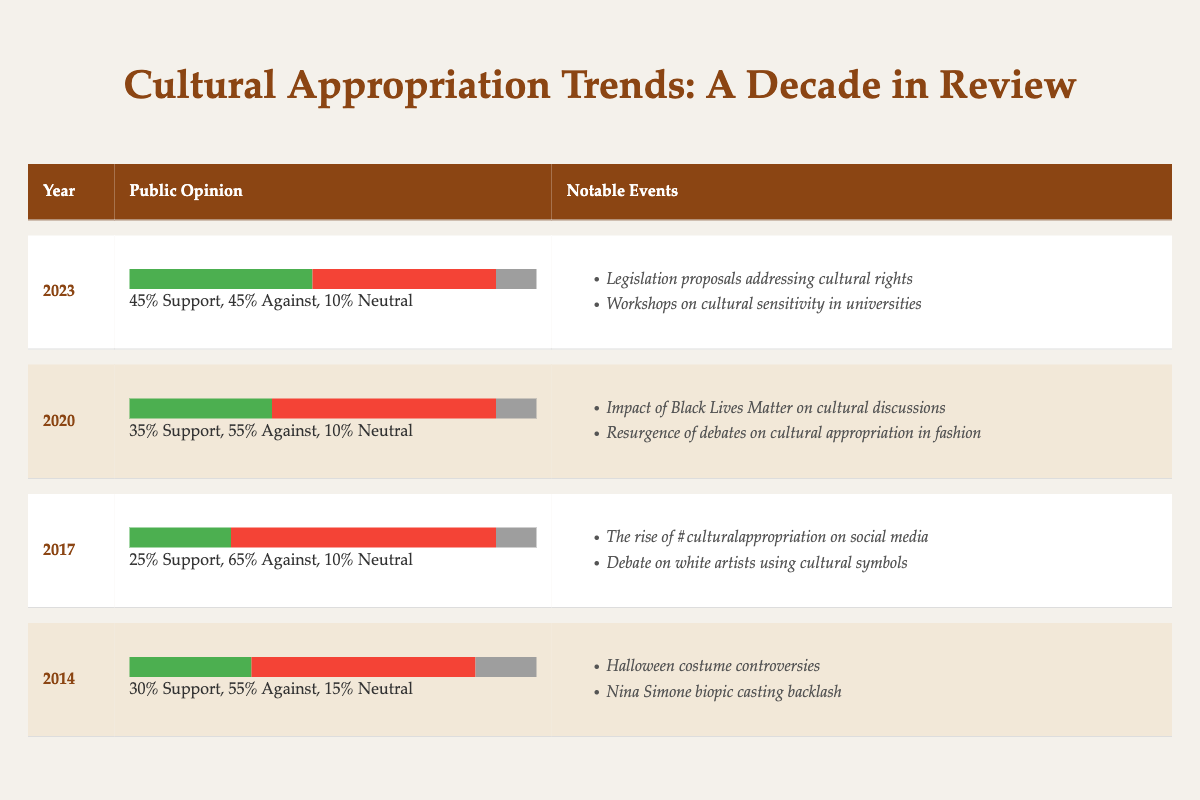What was the percentage of public support for cultural appropriation in 2023? According to the table, the public opinion percentage for support in 2023 is explicitly stated as 45%.
Answer: 45% Which year had the highest percentage of people against cultural appropriation? By examining the table, we find that 2017 had the highest percentage against, which is 65%.
Answer: 2017 What is the difference in public support between 2013 and 2022? The support percentages for 2013 and 2022 are 35% and 40%, respectively. The difference is calculated as 40% - 35% = 5%.
Answer: 5% Did any year have more people against cultural appropriation than in favor of it? Yes, in every year from 2013 to 2023, the percentage of people against cultural appropriation was higher than those in favor.
Answer: Yes What was the average percentage of neutral opinion from 2013 to 2022? The neutral percentages for the years are 15%, 15%, 14%, 8%, 10%, 10%, 12%, and 12%. Adding these gives 96%, and dividing by 8 (the number of years) gives an average of 12%.
Answer: 12% Which notable event in 2016 is associated with the highest percentage against cultural appropriation? In 2016, the percentage against cultural appropriation was 60%. The notable event listed for this year is the controversy over cultural elements in Beyoncé's Lemonade.
Answer: Controversy over cultural elements in Beyoncé's Lemonade What trend can be observed in the public support percentage from 2013 to 2023? By comparing the public support percentages year by year, it starts at 35% in 2013, drops to 25% in 2017, before gradually increasing to 45% in 2023, indicating a rising trend in support over the decade.
Answer: Rising trend How many notable events are listed for the year 2020? The table specifies that there are two notable events for the year 2020 related to cultural appropriation discussions.
Answer: 2 What year saw a public opinion percentage with equal support and opposition? The table indicates that in 2023, the public opinion percentage for support and against cultural appropriation were both 45%.
Answer: 2023 